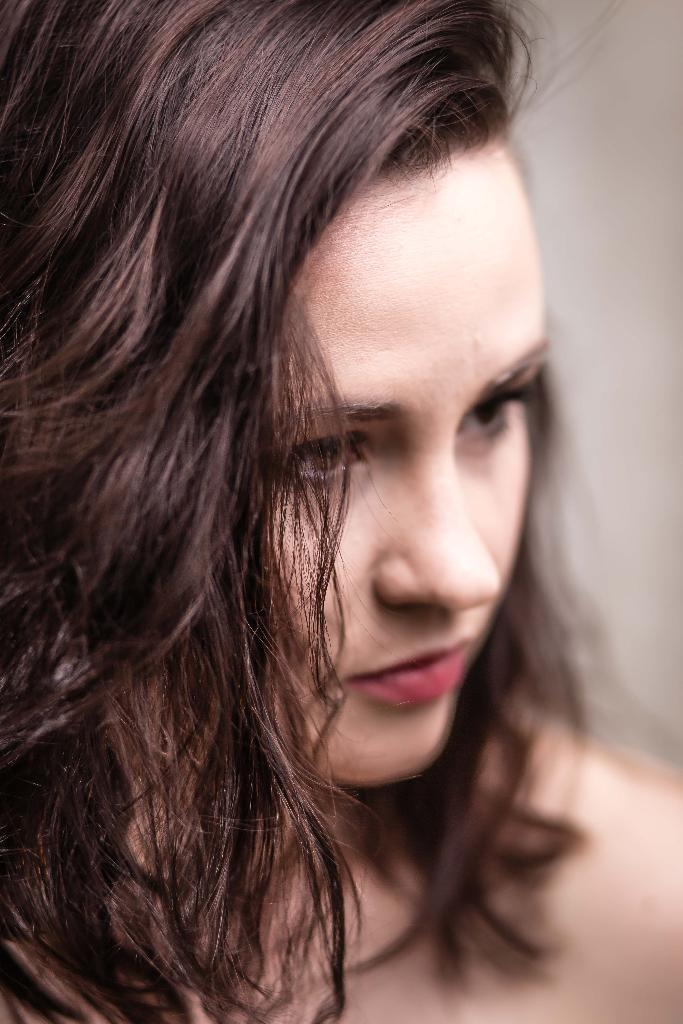Who is the main subject in the image? There is a girl in the image. Can you describe the background of the image? The background of the image is blurred. What type of orange is the girl holding in the image? There is no orange present in the image; the girl is the only subject visible. 